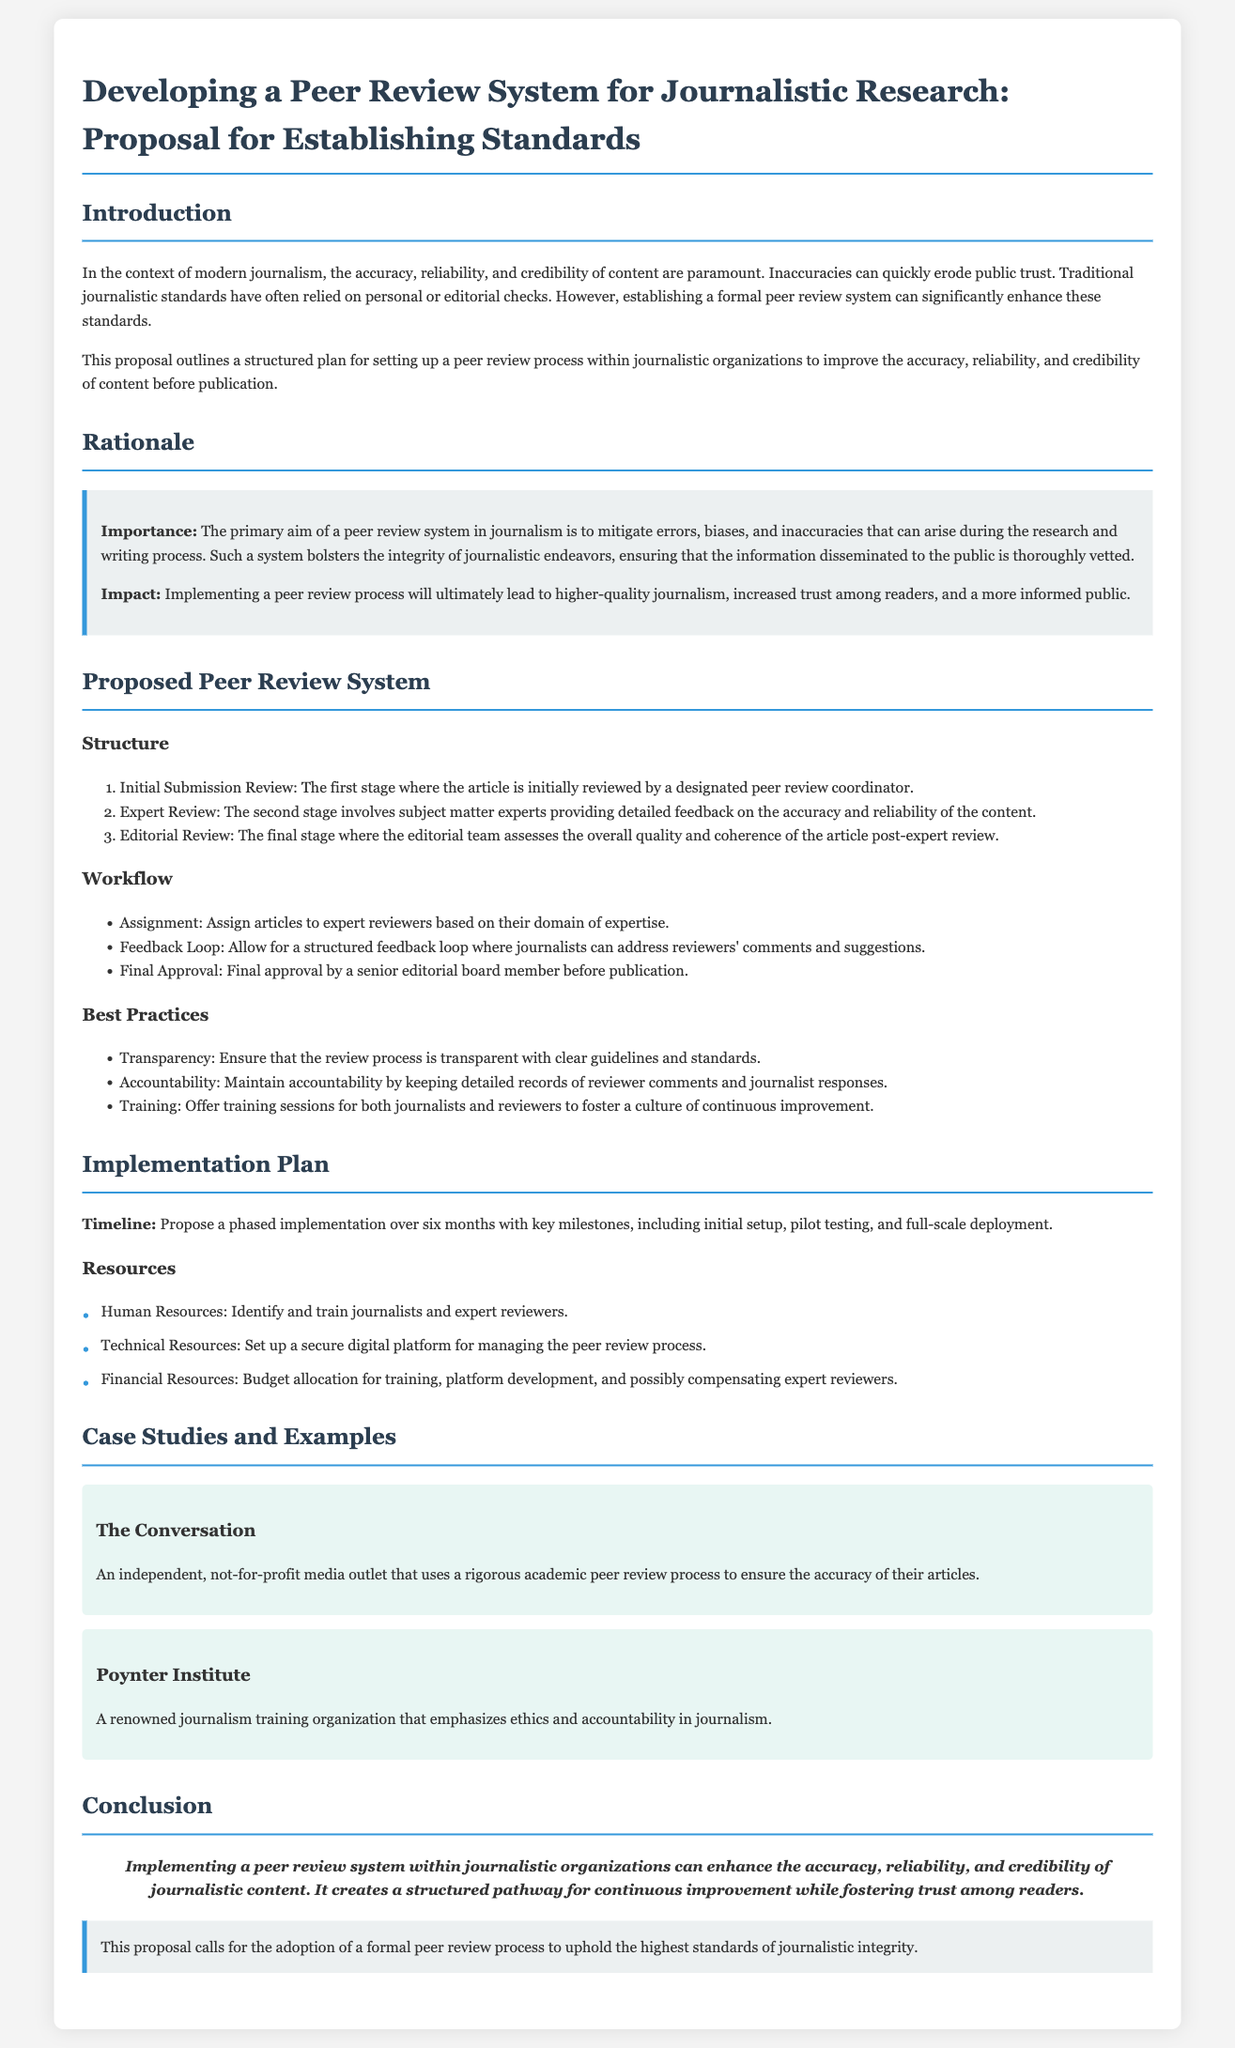What is the title of the proposal? The title is mentioned at the top of the document and summarizes the main focus of the proposal.
Answer: Developing a Peer Review System for Journalistic Research: Proposal for Establishing Standards What is the primary aim of the peer review system in journalism? This information is found in the Rationale section, outlining the goal of the system.
Answer: Mitigate errors, biases, and inaccuracies How many stages are there in the proposed peer review structure? The structure section lists the stages involved in the review process.
Answer: Three Name one best practice for the peer review process. Best practices are listed in a section dedicated to maintaining standards in peer review.
Answer: Transparency What organization is mentioned as a case study for using peer review? The document provides specific examples of organizations implementing a peer review process.
Answer: The Conversation What is the proposed timeline for implementation? The Implementation Plan section suggests a duration for the rollout of the system.
Answer: Six months Who is responsible for the initial submission review? The structure of the review process specifies the role responsible for the first review.
Answer: Peer review coordinator What is a key resource required for the peer review system? Resources necessary for the implementation are outlined in the Implementation Plan.
Answer: Human Resources 